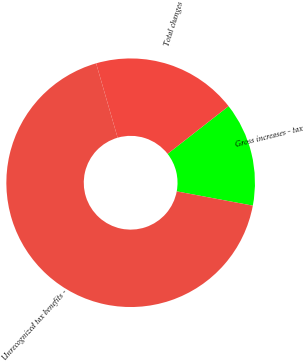Convert chart. <chart><loc_0><loc_0><loc_500><loc_500><pie_chart><fcel>Gross increases - tax<fcel>Total changes<fcel>Unrecognized tax benefits -<nl><fcel>13.51%<fcel>18.92%<fcel>67.57%<nl></chart> 